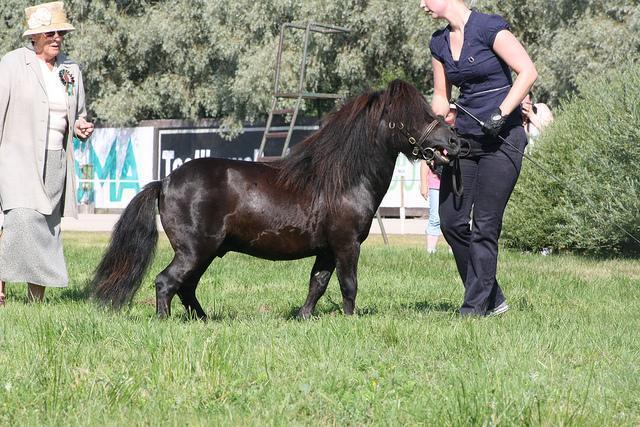How many people are there?
Give a very brief answer. 2. 